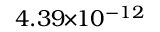<formula> <loc_0><loc_0><loc_500><loc_500>4 . 3 9 \, \times \, 1 0 ^ { - 1 2 }</formula> 